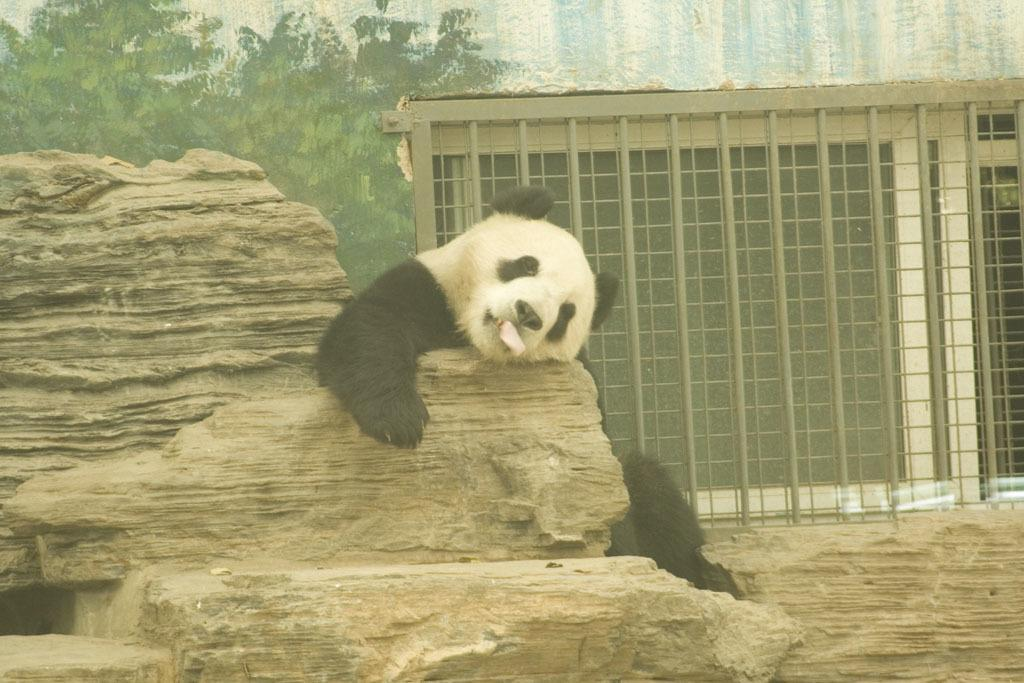What animal is sitting on a stone in the image? There is a bear sitting on a stone in the image. What is the color scheme of the image? The image is in black and white. What type of vegetation can be seen on the left side of the image? There are trees on the left side of the image. What is present on the right side of the image? There is an iron grill on the right side of the image. What type of whip can be seen in the bear's hand in the image? There is no whip present in the image, and the bear does not have a hand to hold a whip. 